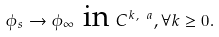Convert formula to latex. <formula><loc_0><loc_0><loc_500><loc_500>\phi _ { s } \rightarrow \phi _ { \infty } \text { in } C ^ { k , \ a } , \forall k \geq 0 .</formula> 